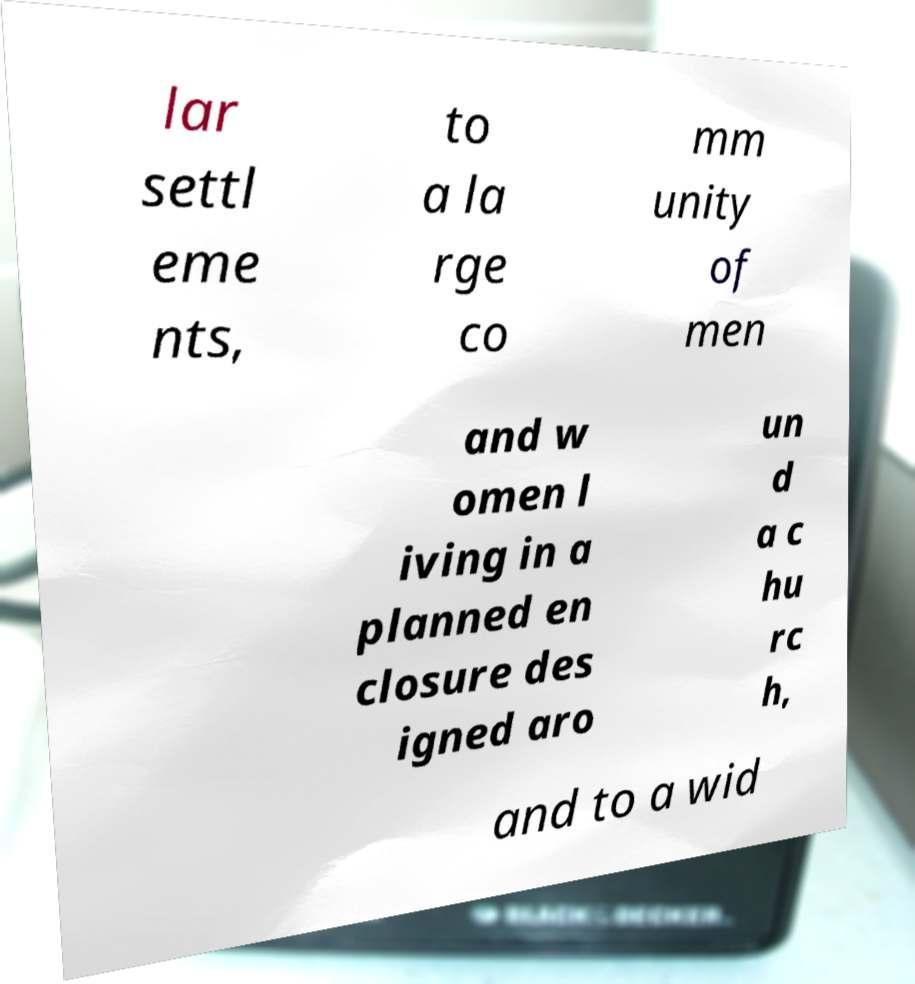Please read and relay the text visible in this image. What does it say? lar settl eme nts, to a la rge co mm unity of men and w omen l iving in a planned en closure des igned aro un d a c hu rc h, and to a wid 